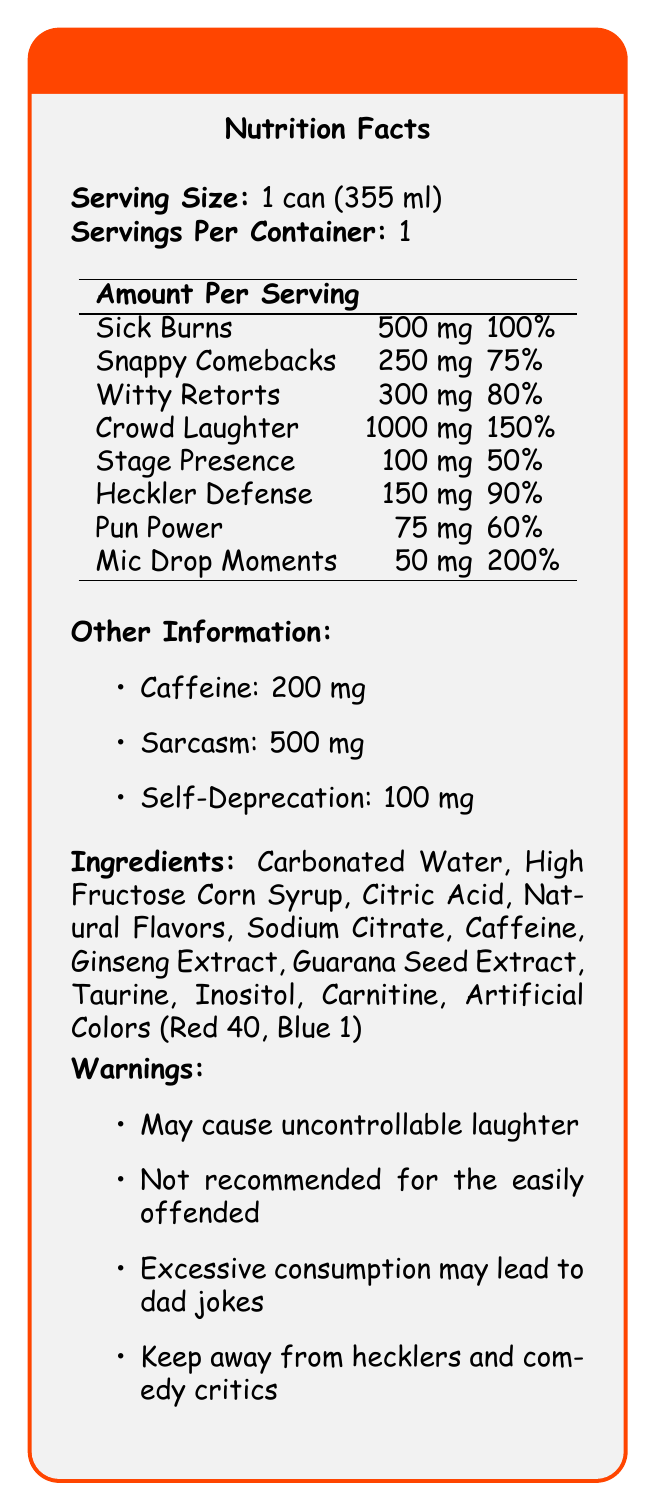What is the serving size for the Roast Battle Energy Drink? The document specifies that the serving size is 1 can (355 ml) under the "Nutrition Facts" section.
Answer: 1 can (355 ml) How much Sick Burns does one serving contain? The "Amount Per Serving" table lists Sick Burns as containing 500 mg per serving.
Answer: 500 mg What percentage of the Daily Value of Snappy Comebacks does one serving provide? The "Amount Per Serving" table lists Snappy Comebacks as providing 75% of the Daily Value.
Answer: 75% What are the ingredients of the Roast Battle Energy Drink? The document lists all these ingredients under the "Ingredients" section.
Answer: Carbonated Water, High Fructose Corn Syrup, Citric Acid, Natural Flavors, Sodium Citrate, Caffeine, Ginseng Extract, Guarana Seed Extract, Taurine, Inositol, Carnitine, Artificial Colors (Red 40, Blue 1) What is the amount of caffeine per serving? The "Other Information" section lists Caffeine as containing 200 mg per serving.
Answer: 200 mg Which nutrient has the highest Daily Value percentage in this energy drink? A. Sick Burns B. Crowd Laughter C. Mic Drop Moments D. Heckler Defense The "Amount Per Serving" table shows Mic Drop Moments with 200% of the Daily Value, the highest among all nutrients.
Answer: C. Mic Drop Moments Which warning suggests the energy drink is not suitable for everyone? A. May cause uncontrollable laughter B. Not recommended for the easily offended C. Excessive consumption may lead to dad jokes D. Keep away from hecklers and comedy critics While all warnings are humorous, the specific caution about being "Not recommended for the easily offended" hints at broader unsuitability.
Answer: B. Not recommended for the easily offended Is the drink recommended for hecklers and comedy critics? The warning section advises to "Keep away from hecklers and comedy critics."
Answer: No How many Servings Per Container are there? The document specifies there is only one serving per container in the "Nutrition Facts" section.
Answer: 1 What is the main idea of this document? The document provides a humorous take on classic nutrition labels, detailing nutrients like Sick Burns and Mic Drop Moments, along with warnings intended to entertain, such as the risk of uncontrollable laughter and dad jokes.
Answer: Description of the comedic-themed nutrition facts of Roast Battle Energy Drink. How much Sarcasm does the beverage contain? The "Other Information" section lists Sarcasm as containing 500 mg.
Answer: 500 mg What effect might excessive consumption of this energy drink have? The warning section humorously suggests that excessive consumption could lead to dad jokes.
Answer: May lead to dad jokes How much Crowd Laughter does one serving provide? A. 100 mg B. 300 mg C. 500 mg D. 1000 mg The "Amount Per Serving" table shows Crowd Laughter at 1000 mg per serving.
Answer: D. 1000 mg How much Self-Deprecation is in the drink? The "Other Information" section lists Self-Deprecation as containing 100 mg.
Answer: 100 mg Can you determine the price of the Roast Battle Energy Drink from the document? The document does not provide any information regarding the price of the energy drink.
Answer: Not enough information 